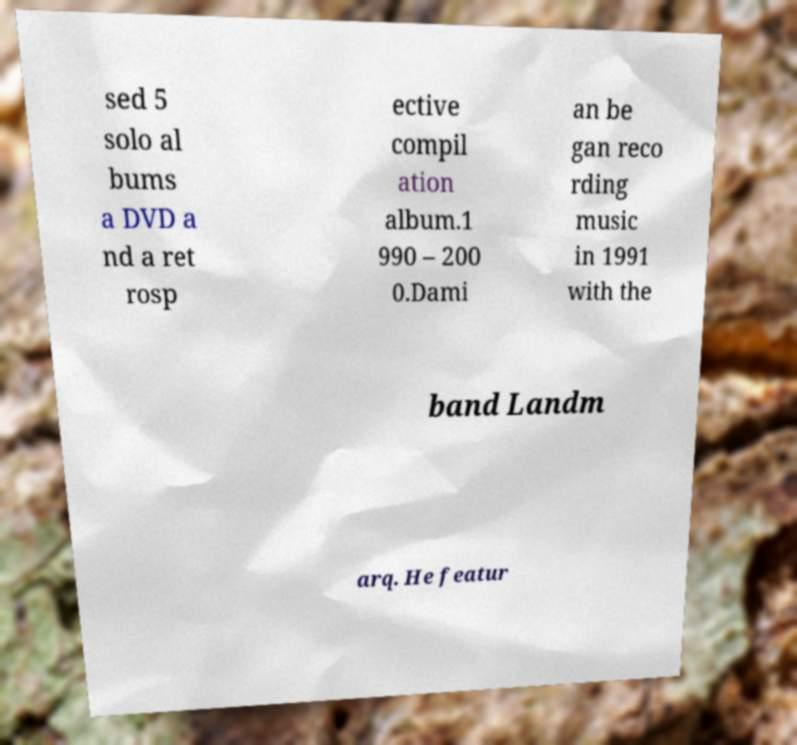Please identify and transcribe the text found in this image. sed 5 solo al bums a DVD a nd a ret rosp ective compil ation album.1 990 – 200 0.Dami an be gan reco rding music in 1991 with the band Landm arq. He featur 